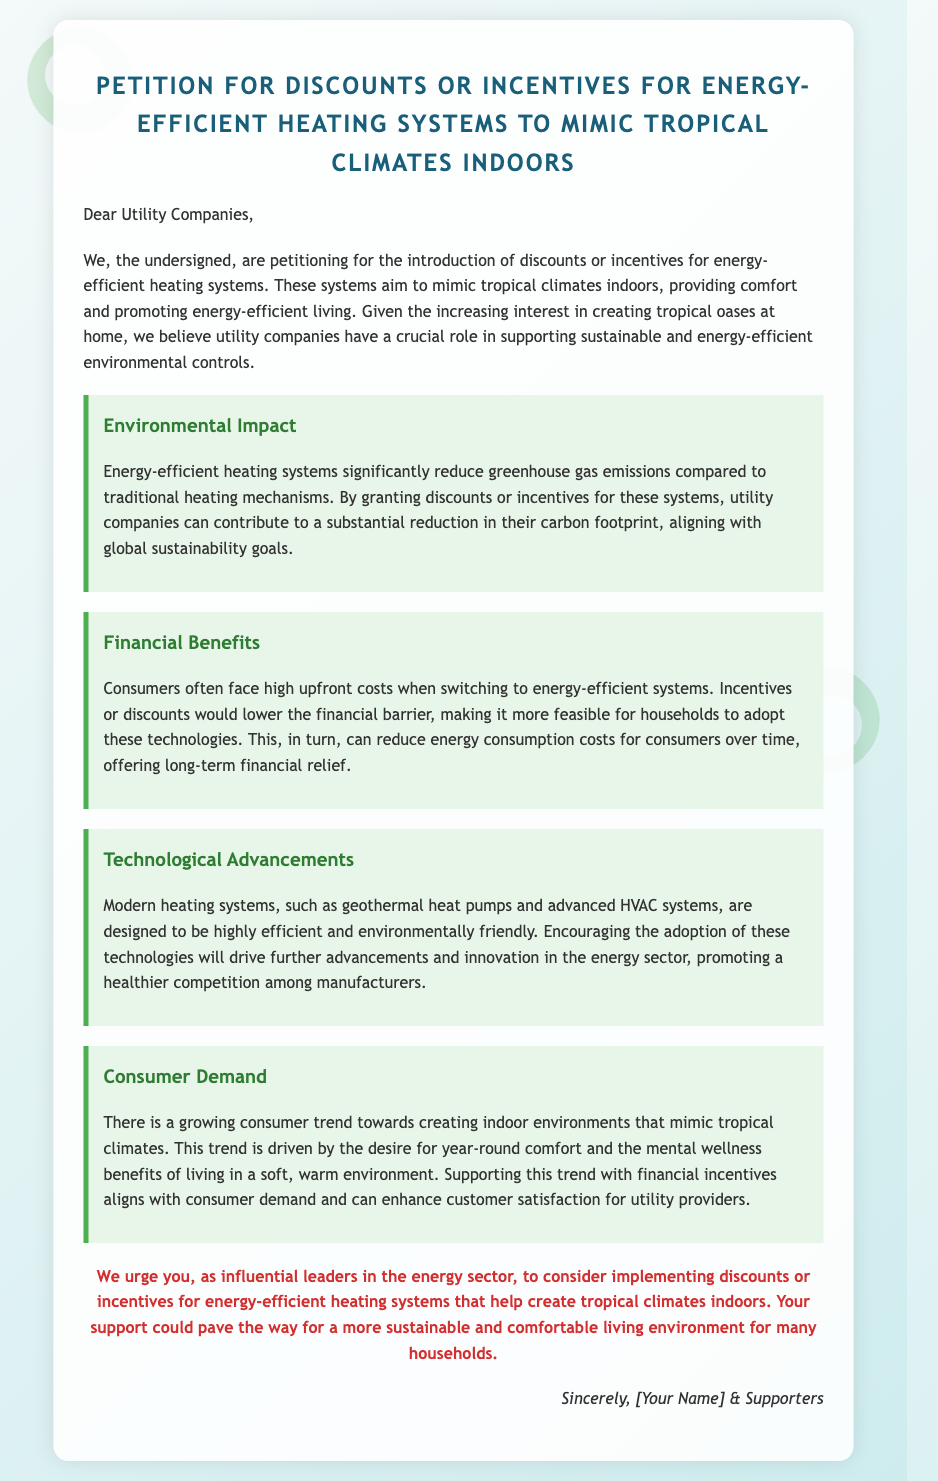What is the title of the petition? The title is explicitly stated at the top of the document, which is "Petition for Discounts or Incentives for Energy-Efficient Heating Systems to Mimic Tropical Climates Indoors."
Answer: Petition for Discounts or Incentives for Energy-Efficient Heating Systems to Mimic Tropical Climates Indoors Who is the intended recipient of this petition? The document begins with a greeting that addresses "Utility Companies," indicating they are the intended recipients.
Answer: Utility Companies What is one proposed benefit of energy-efficient heating systems mentioned in the petition? The document highlights several benefits; one mentioned is "significantly reduce greenhouse gas emissions."
Answer: significantly reduce greenhouse gas emissions What financial aspect does the petition address regarding energy-efficient systems? The document states that consumers often face "high upfront costs" when switching to these systems, pointing to the financial barrier they create.
Answer: high upfront costs What is a consumer trend mentioned in the petition? The document discusses a trend toward "creating indoor environments that mimic tropical climates."
Answer: creating indoor environments that mimic tropical climates What type of systems does the petition advocate for? The document details that it advocates for "energy-efficient heating systems."
Answer: energy-efficient heating systems What closing phrase is used in the document? The closing of the document includes the phrase "Sincerely, [Your Name] & Supporters," typical for a petition.
Answer: Sincerely, [Your Name] & Supporters How many justifications are provided in the petition? The document contains four sections that provide justifications regarding environmental impact, financial benefits, technological advancements, and consumer demand.
Answer: four 